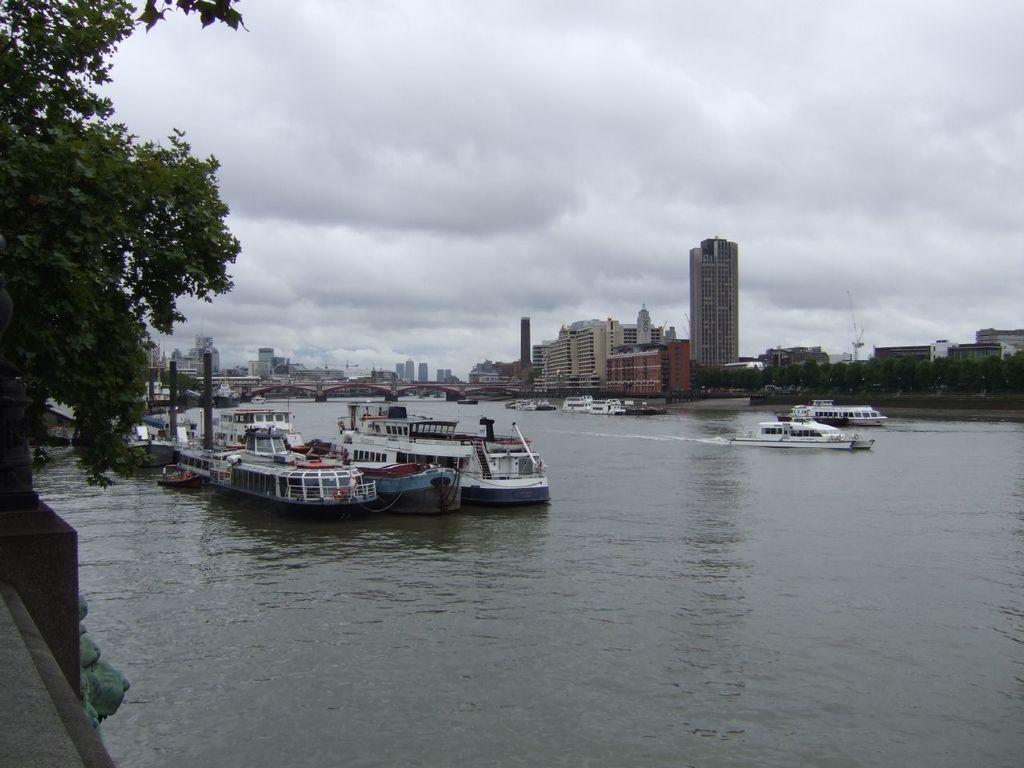Describe this image in one or two sentences. In this image ships are sailing on a lake, there is a bridge on the lake, in the background there are buildings, in the left side there is a tree in the top there is cloudy sky. 